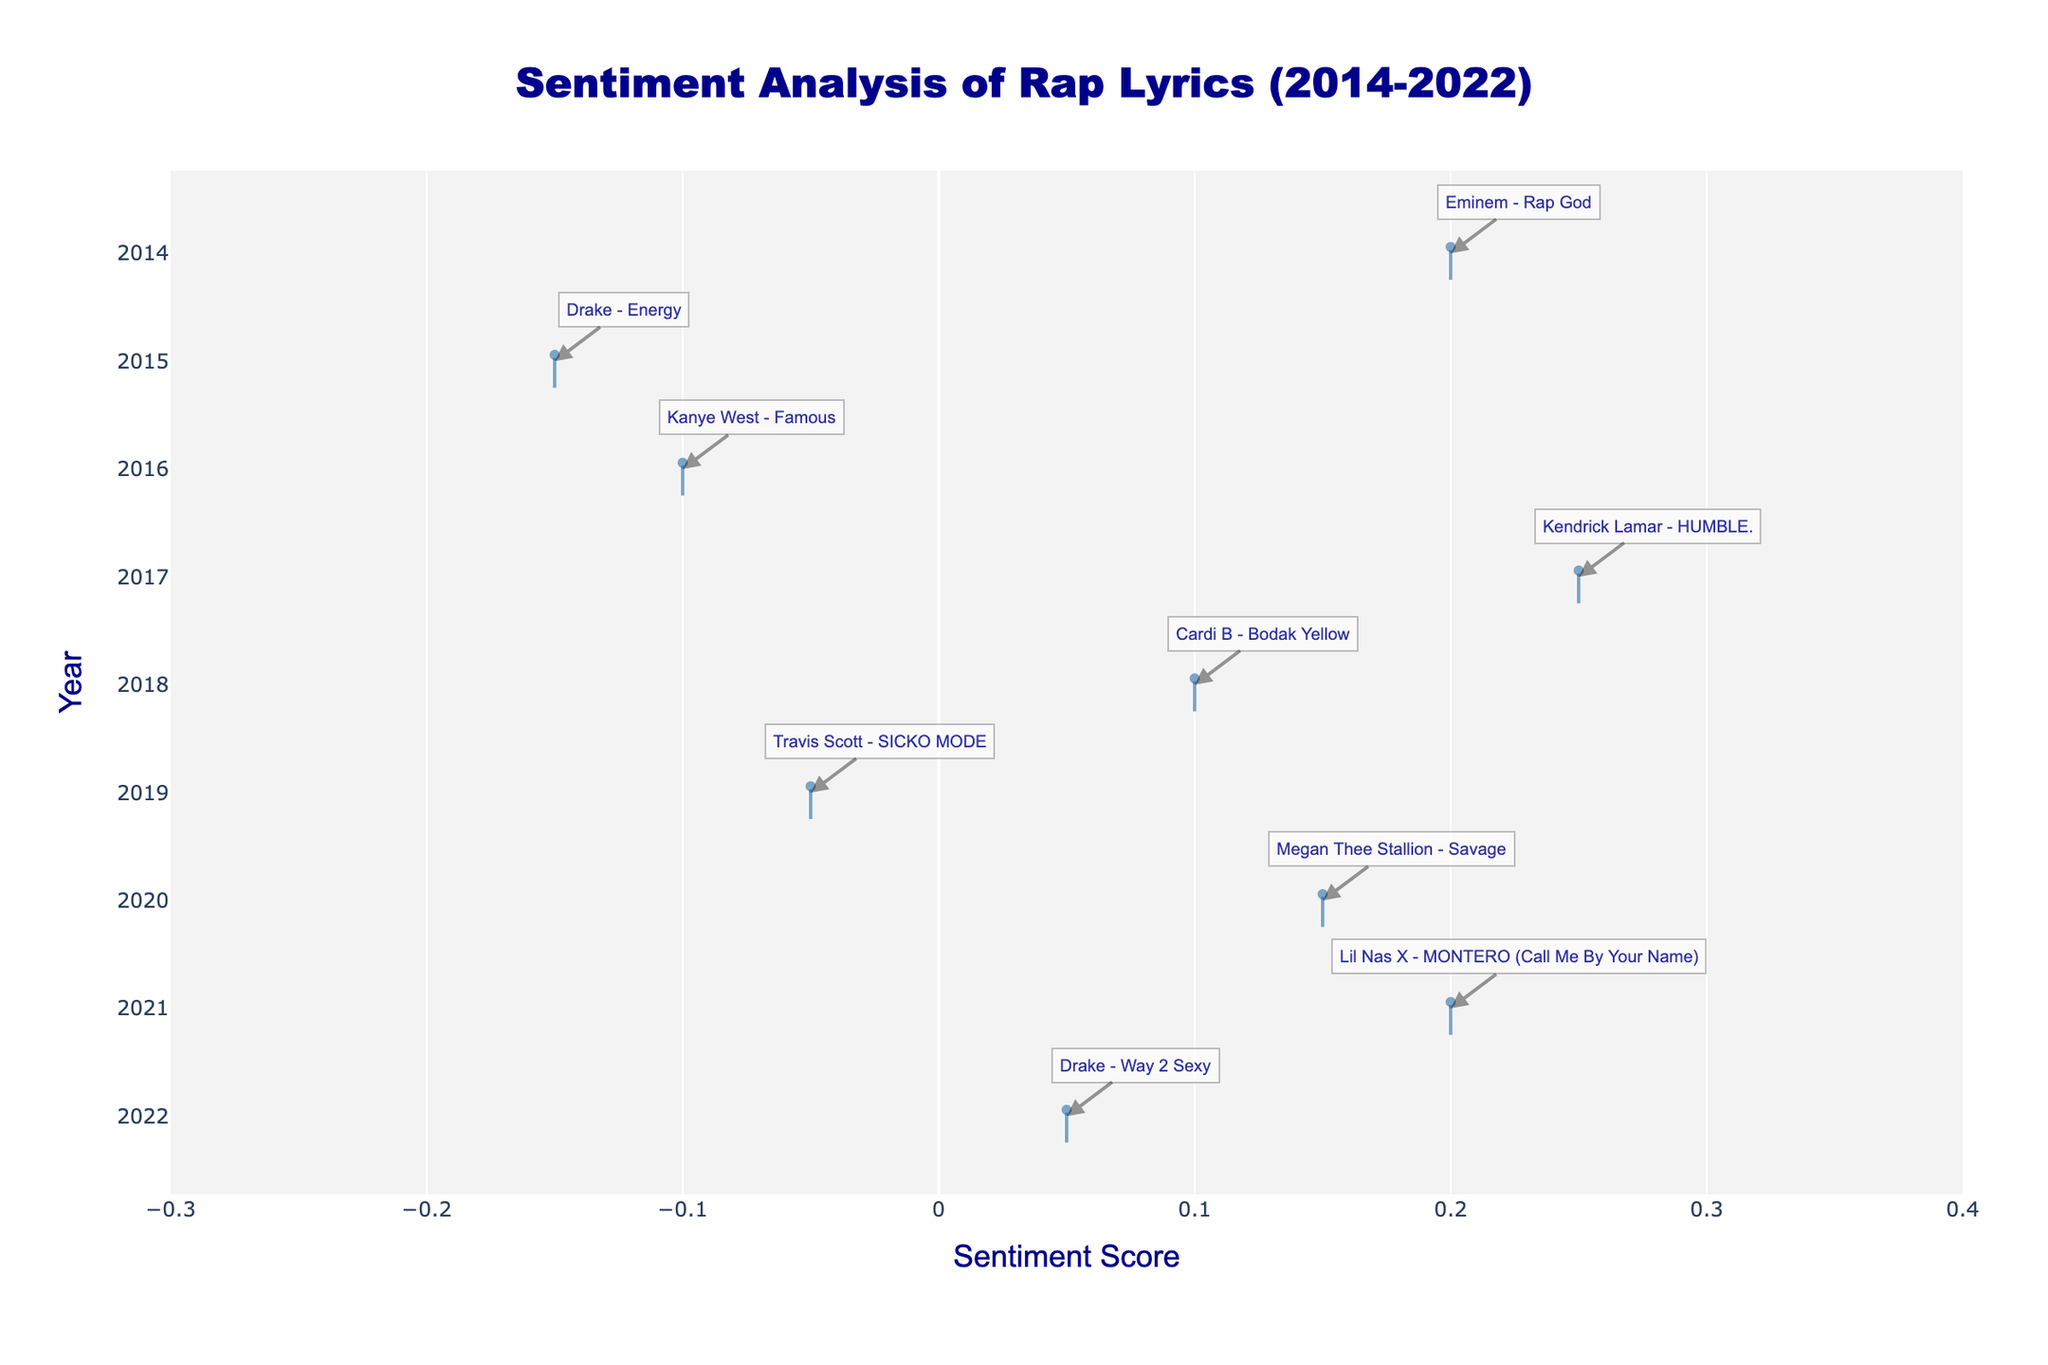How many years are included in the analysis? The figure shows the violin plots for each year listed on the y-axis. Counting the labels, we see the years 2014 through 2022.
Answer: 9 Which year has the highest average sentiment score? The violin plots show the average sentiment score for each year with a meanline. The highest meanline can be visually compared across the years. 2017 appears to have the highest average sentiment score.
Answer: 2017 Does any year have a sentiment score below -0.1? By examining the violin plots, none of the points within the violins extend below -0.1 for any year. The lowest point is in 2015, and it's only slightly below zero.
Answer: No Which year has the most positive sentiment score and what song and artist is it associated with? By observing the annotations and the x-axis range, we can see that 2017 has the most positive sentiment score, associated with Kendrick Lamar's "HUMBLE." which has a sentiment score of 0.25.
Answer: 2017, Kendrick Lamar - HUMBLE Compare the sentiment score of Drake's "Energy" and "Way 2 Sexy". Which one has a more positive sentiment score? By locating both songs on the figure, "Energy" in 2015 and "Way 2 Sexy" in 2022, we see "Way 2 Sexy" has a sentiment score closer to the positive end of the x-axis than "Energy".
Answer: Way 2 Sexy What is the range of sentiment scores for the year 2020? The violin plot for 2020 shows the spread of data points. The points indicated are from Megan Thee Stallion's "Savage" with a sentiment score of 0.15. Since there's only one song, the range is exactly the sentiment score of the song.
Answer: 0.15 Which artist has a song with a sentiment score above 0.2? Checking the annotations for points above 0.2 on the x-axis, we see that Eminem (Rap God, 2014) and Kendrick Lamar (HUMBLE., 2017) both have sentiment scores above 0.2.
Answer: Eminem and Kendrick Lamar Is there a year where all songs have a negative sentiment score? By examining the figures for all years, in no year do all the songs have a sentiment score below zero. The closest year is 2015 with Drake's "Energy," but that's just one data point.
Answer: No Which years show data points for multiple artists and songs? By checking each year visually, we see each year has annotations for just one artist and song except 2014 and 2015.
Answer: None 